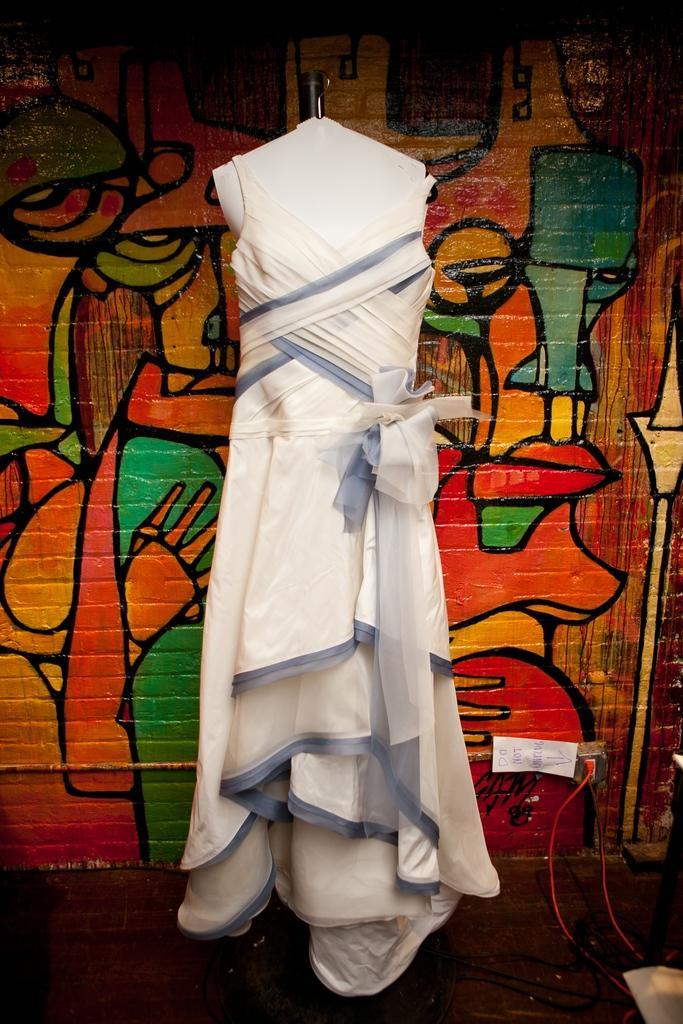Could you give a brief overview of what you see in this image? This image is taken indoors. At the bottom of the image there is a floor. In the background there is a wall with paintings on it. In the middle of the image there is a mannequin and there is a frock on the mannequin. 